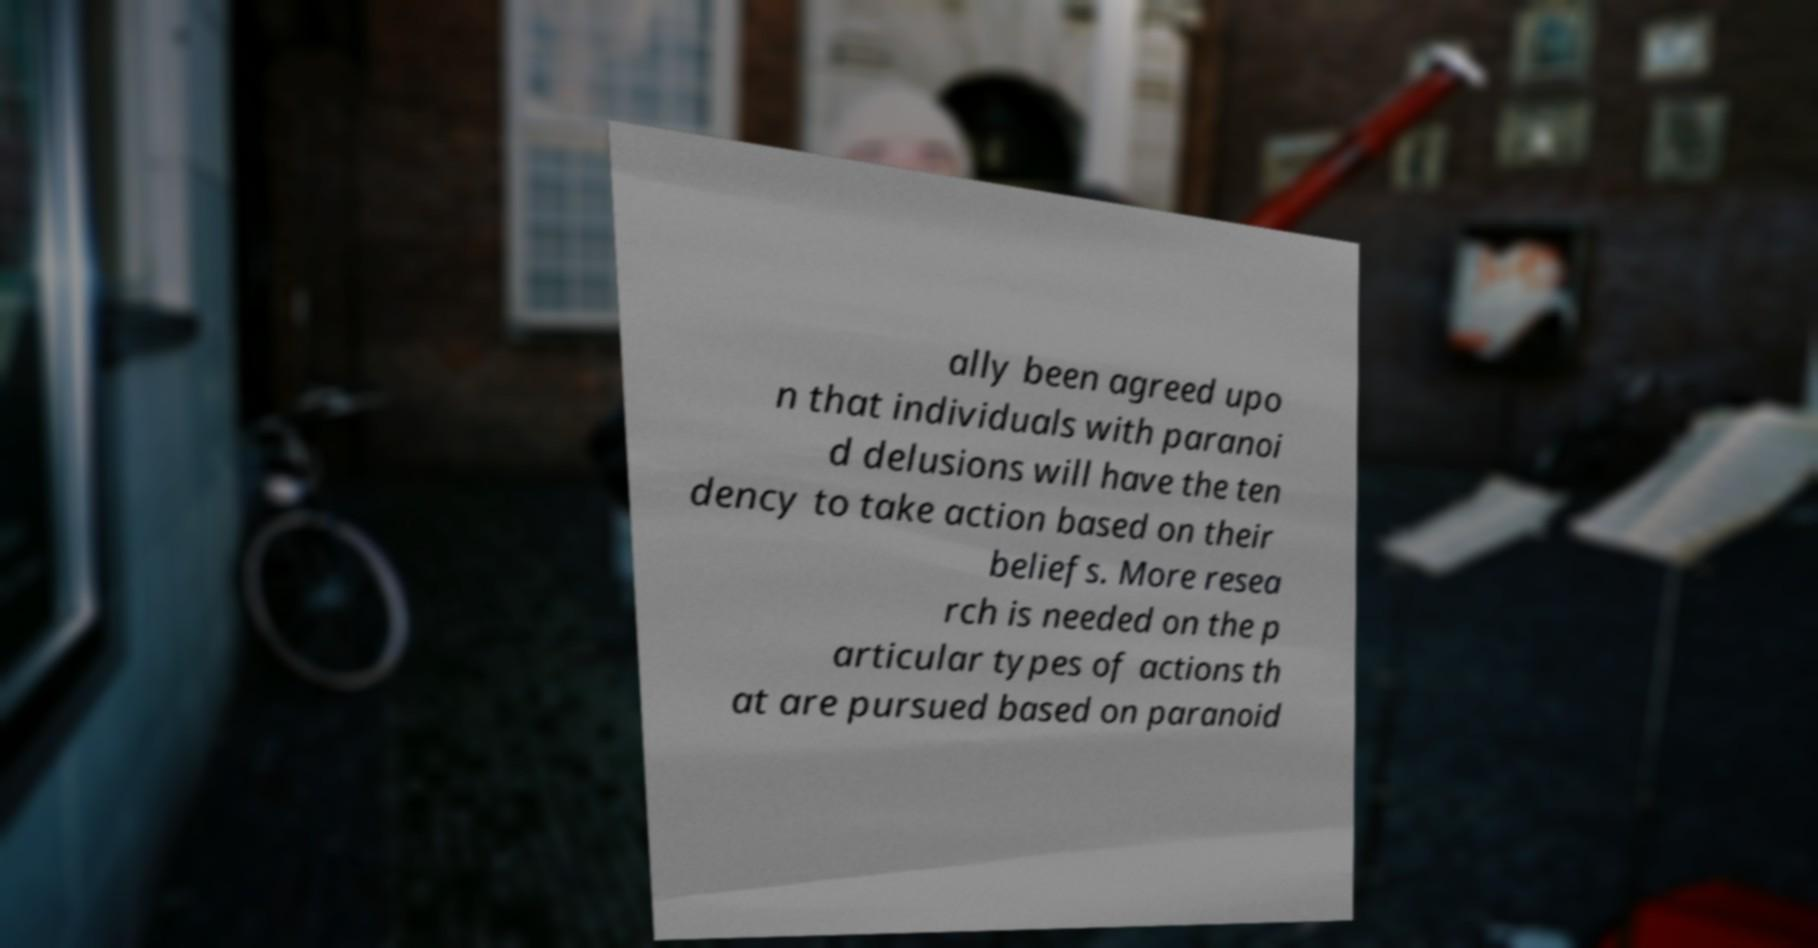Can you read and provide the text displayed in the image?This photo seems to have some interesting text. Can you extract and type it out for me? ally been agreed upo n that individuals with paranoi d delusions will have the ten dency to take action based on their beliefs. More resea rch is needed on the p articular types of actions th at are pursued based on paranoid 